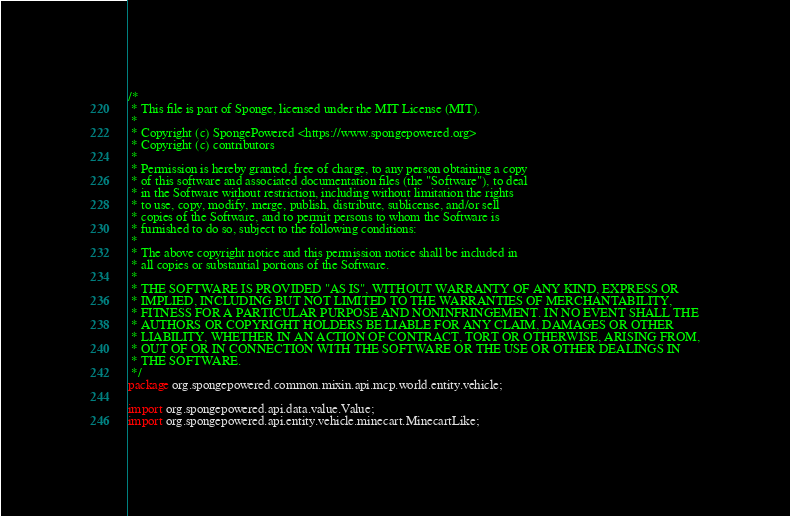<code> <loc_0><loc_0><loc_500><loc_500><_Java_>/*
 * This file is part of Sponge, licensed under the MIT License (MIT).
 *
 * Copyright (c) SpongePowered <https://www.spongepowered.org>
 * Copyright (c) contributors
 *
 * Permission is hereby granted, free of charge, to any person obtaining a copy
 * of this software and associated documentation files (the "Software"), to deal
 * in the Software without restriction, including without limitation the rights
 * to use, copy, modify, merge, publish, distribute, sublicense, and/or sell
 * copies of the Software, and to permit persons to whom the Software is
 * furnished to do so, subject to the following conditions:
 *
 * The above copyright notice and this permission notice shall be included in
 * all copies or substantial portions of the Software.
 *
 * THE SOFTWARE IS PROVIDED "AS IS", WITHOUT WARRANTY OF ANY KIND, EXPRESS OR
 * IMPLIED, INCLUDING BUT NOT LIMITED TO THE WARRANTIES OF MERCHANTABILITY,
 * FITNESS FOR A PARTICULAR PURPOSE AND NONINFRINGEMENT. IN NO EVENT SHALL THE
 * AUTHORS OR COPYRIGHT HOLDERS BE LIABLE FOR ANY CLAIM, DAMAGES OR OTHER
 * LIABILITY, WHETHER IN AN ACTION OF CONTRACT, TORT OR OTHERWISE, ARISING FROM,
 * OUT OF OR IN CONNECTION WITH THE SOFTWARE OR THE USE OR OTHER DEALINGS IN
 * THE SOFTWARE.
 */
package org.spongepowered.common.mixin.api.mcp.world.entity.vehicle;

import org.spongepowered.api.data.value.Value;
import org.spongepowered.api.entity.vehicle.minecart.MinecartLike;</code> 